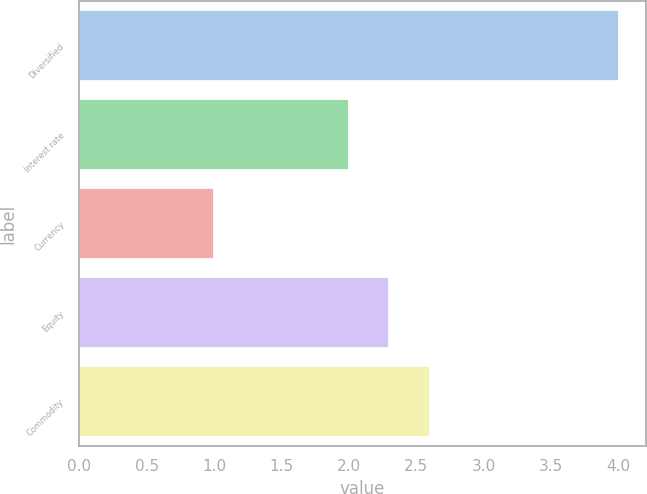Convert chart to OTSL. <chart><loc_0><loc_0><loc_500><loc_500><bar_chart><fcel>Diversified<fcel>Interest rate<fcel>Currency<fcel>Equity<fcel>Commodity<nl><fcel>4<fcel>2<fcel>1<fcel>2.3<fcel>2.6<nl></chart> 